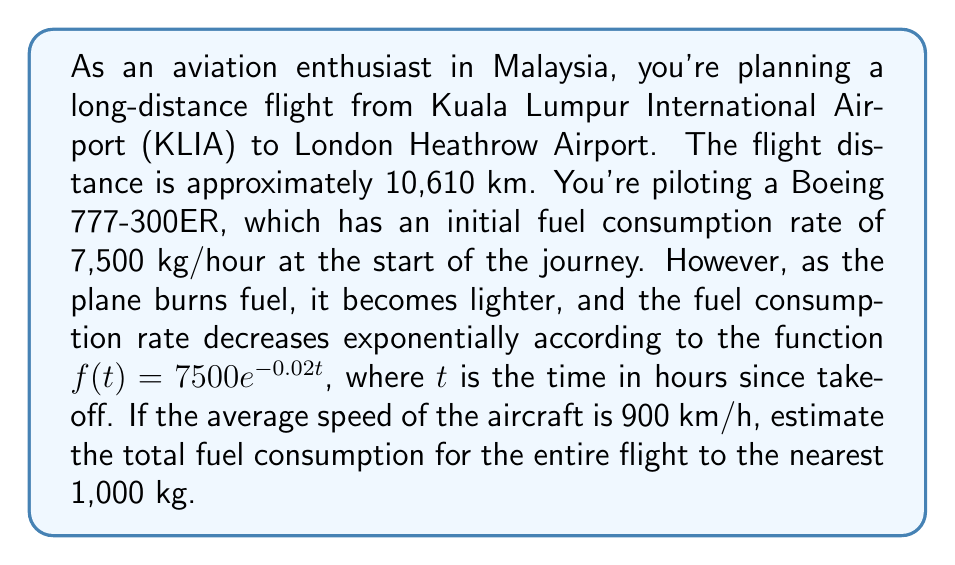Help me with this question. Let's approach this problem step by step:

1) First, calculate the total flight time:
   $$\text{Flight time} = \frac{\text{Distance}}{\text{Average speed}} = \frac{10,610 \text{ km}}{900 \text{ km/h}} \approx 11.79 \text{ hours}$$

2) The fuel consumption rate is given by the function $f(t) = 7500e^{-0.02t}$ kg/hour.

3) To find the total fuel consumption, we need to integrate this function over the flight time:

   $$\text{Total fuel} = \int_0^{11.79} 7500e^{-0.02t} dt$$

4) Solve the integral:
   
   $$\begin{align}
   \text{Total fuel} &= -7500 \cdot \frac{1}{-0.02} \cdot e^{-0.02t} \Big|_0^{11.79} \\
   &= 375000 \cdot (e^{-0.02 \cdot 11.79} - e^{-0.02 \cdot 0}) \\
   &= 375000 \cdot (e^{-0.2358} - 1) \\
   &= 375000 \cdot (0.7899 - 1) \\
   &= 375000 \cdot (-0.2101) \\
   &= -78,787.5 \text{ kg}
   \end{align}$$

5) The negative sign indicates fuel consumed. Take the absolute value and round to the nearest 1,000 kg.
Answer: The estimated total fuel consumption for the flight from KLIA to London Heathrow is approximately 79,000 kg. 